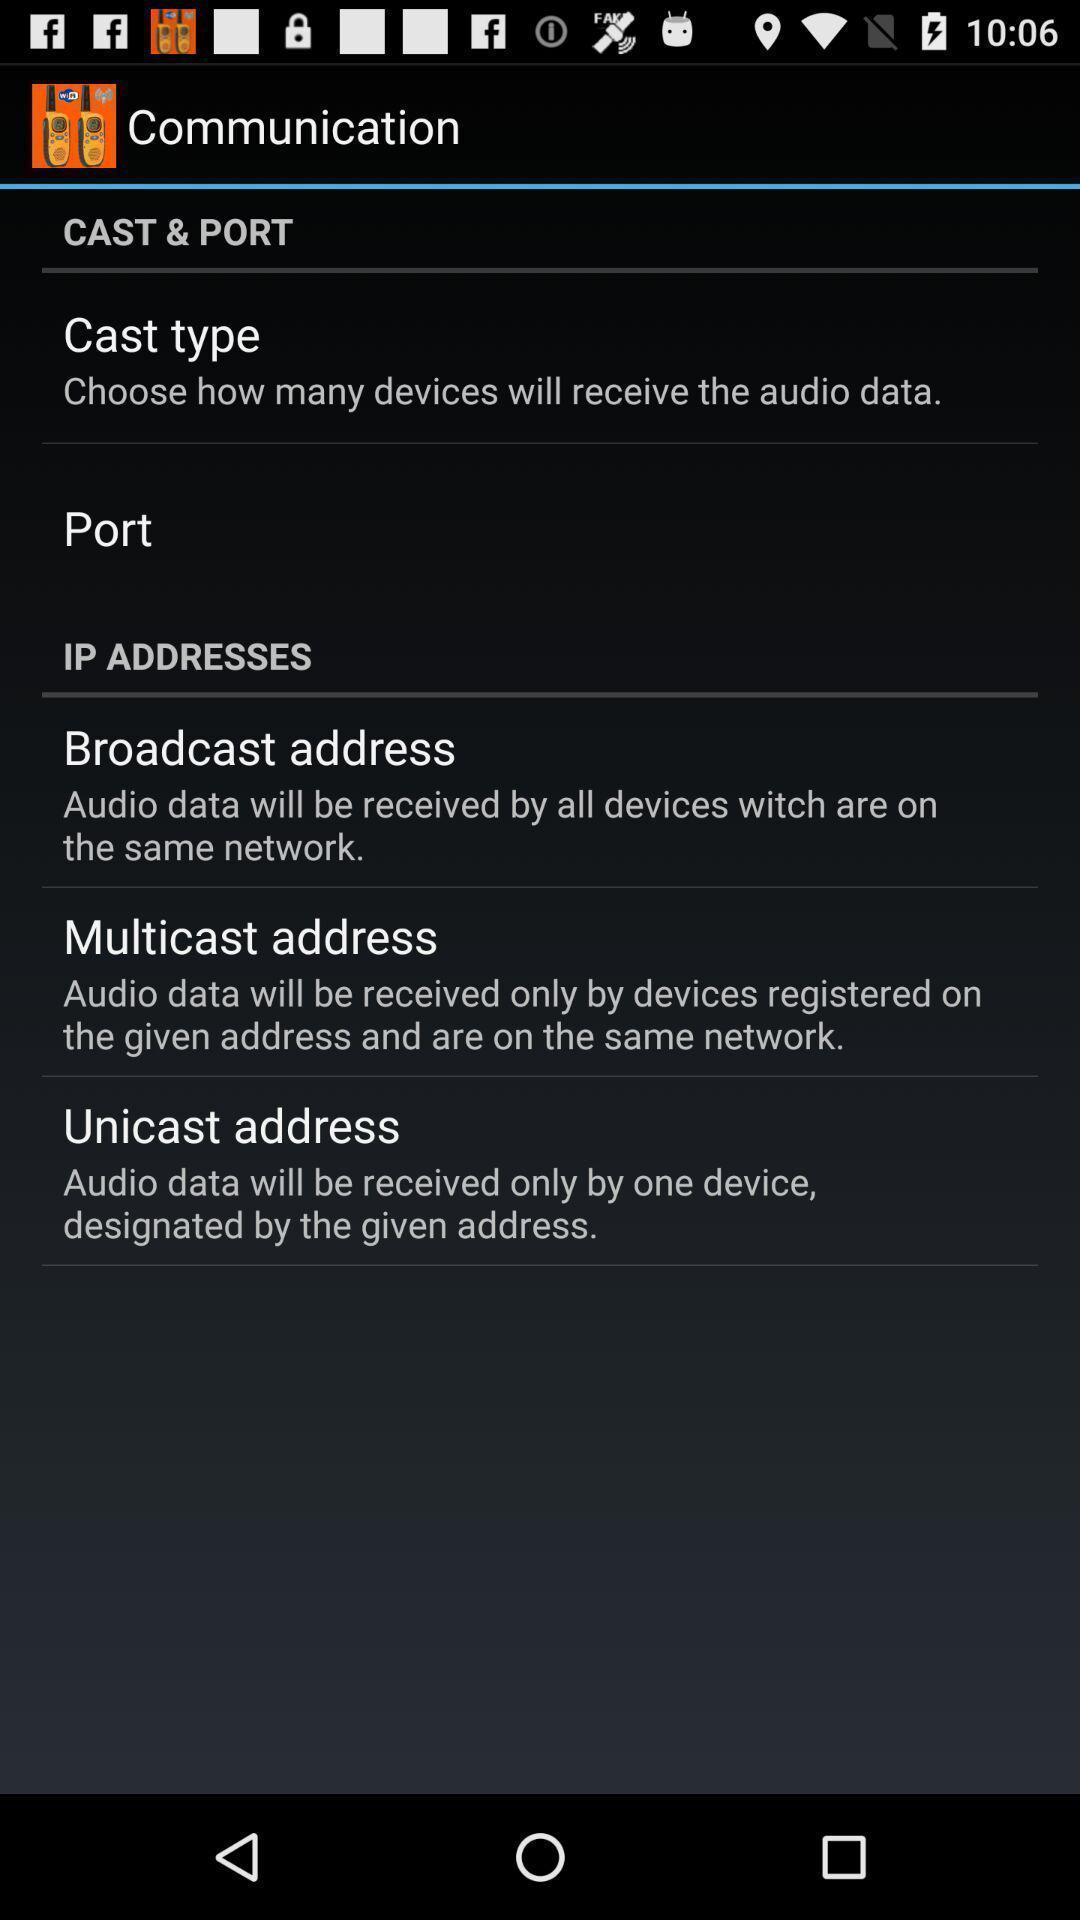Give me a narrative description of this picture. Screen shows list of communication. 